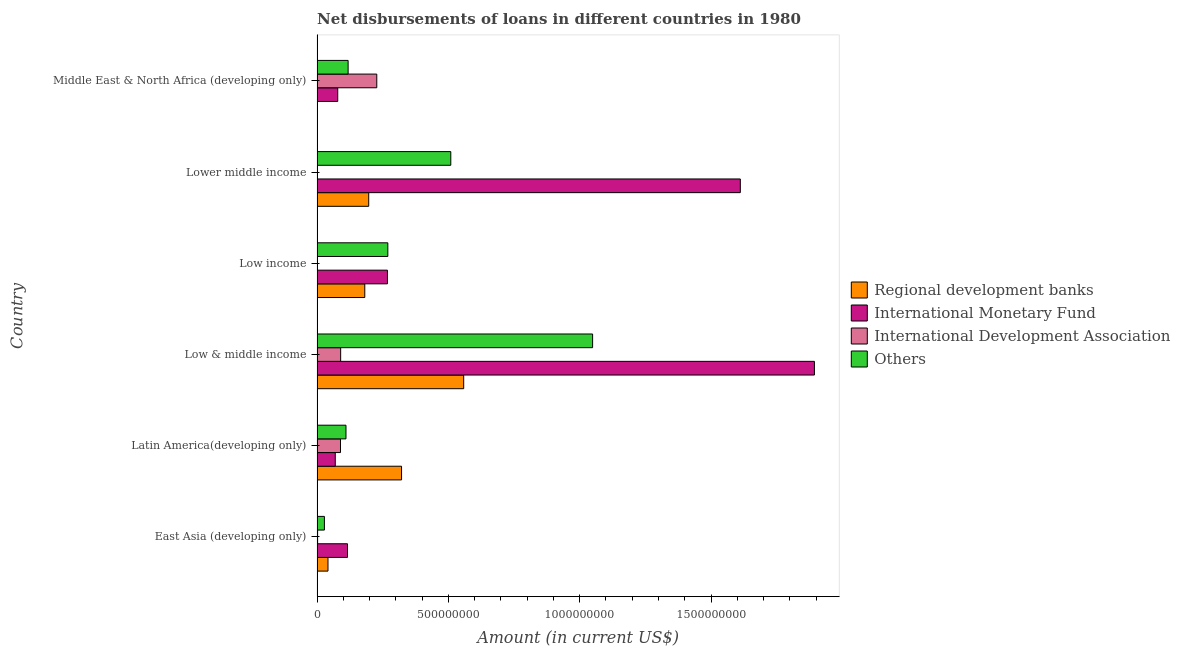How many different coloured bars are there?
Your answer should be compact. 4. How many groups of bars are there?
Offer a terse response. 6. Are the number of bars per tick equal to the number of legend labels?
Your answer should be compact. No. Are the number of bars on each tick of the Y-axis equal?
Ensure brevity in your answer.  No. How many bars are there on the 1st tick from the top?
Ensure brevity in your answer.  4. How many bars are there on the 4th tick from the bottom?
Your answer should be very brief. 3. In how many cases, is the number of bars for a given country not equal to the number of legend labels?
Your response must be concise. 2. What is the amount of loan disimbursed by other organisations in Low & middle income?
Give a very brief answer. 1.05e+09. Across all countries, what is the maximum amount of loan disimbursed by international development association?
Offer a very short reply. 2.27e+08. Across all countries, what is the minimum amount of loan disimbursed by international monetary fund?
Your answer should be very brief. 6.94e+07. What is the total amount of loan disimbursed by international development association in the graph?
Your answer should be very brief. 4.09e+08. What is the difference between the amount of loan disimbursed by international development association in Low & middle income and that in Middle East & North Africa (developing only)?
Offer a terse response. -1.38e+08. What is the difference between the amount of loan disimbursed by international monetary fund in Middle East & North Africa (developing only) and the amount of loan disimbursed by regional development banks in East Asia (developing only)?
Keep it short and to the point. 3.71e+07. What is the average amount of loan disimbursed by regional development banks per country?
Provide a short and direct response. 2.17e+08. What is the difference between the amount of loan disimbursed by regional development banks and amount of loan disimbursed by other organisations in Lower middle income?
Your answer should be very brief. -3.13e+08. In how many countries, is the amount of loan disimbursed by regional development banks greater than 100000000 US$?
Make the answer very short. 4. What is the ratio of the amount of loan disimbursed by other organisations in Latin America(developing only) to that in Middle East & North Africa (developing only)?
Provide a succinct answer. 0.93. Is the amount of loan disimbursed by international development association in East Asia (developing only) less than that in Low & middle income?
Keep it short and to the point. Yes. What is the difference between the highest and the second highest amount of loan disimbursed by other organisations?
Provide a succinct answer. 5.40e+08. What is the difference between the highest and the lowest amount of loan disimbursed by international development association?
Offer a terse response. 2.27e+08. In how many countries, is the amount of loan disimbursed by regional development banks greater than the average amount of loan disimbursed by regional development banks taken over all countries?
Your response must be concise. 2. Is the sum of the amount of loan disimbursed by international monetary fund in East Asia (developing only) and Middle East & North Africa (developing only) greater than the maximum amount of loan disimbursed by regional development banks across all countries?
Provide a succinct answer. No. Are all the bars in the graph horizontal?
Provide a short and direct response. Yes. What is the difference between two consecutive major ticks on the X-axis?
Provide a succinct answer. 5.00e+08. Does the graph contain any zero values?
Your answer should be very brief. Yes. Where does the legend appear in the graph?
Give a very brief answer. Center right. How many legend labels are there?
Give a very brief answer. 4. What is the title of the graph?
Give a very brief answer. Net disbursements of loans in different countries in 1980. What is the label or title of the Y-axis?
Provide a succinct answer. Country. What is the Amount (in current US$) of Regional development banks in East Asia (developing only)?
Your answer should be compact. 4.16e+07. What is the Amount (in current US$) in International Monetary Fund in East Asia (developing only)?
Provide a succinct answer. 1.16e+08. What is the Amount (in current US$) in International Development Association in East Asia (developing only)?
Ensure brevity in your answer.  2.14e+06. What is the Amount (in current US$) in Others in East Asia (developing only)?
Offer a very short reply. 2.80e+07. What is the Amount (in current US$) in Regional development banks in Latin America(developing only)?
Make the answer very short. 3.22e+08. What is the Amount (in current US$) of International Monetary Fund in Latin America(developing only)?
Ensure brevity in your answer.  6.94e+07. What is the Amount (in current US$) in International Development Association in Latin America(developing only)?
Provide a succinct answer. 8.93e+07. What is the Amount (in current US$) in Others in Latin America(developing only)?
Offer a very short reply. 1.10e+08. What is the Amount (in current US$) of Regional development banks in Low & middle income?
Your answer should be compact. 5.58e+08. What is the Amount (in current US$) of International Monetary Fund in Low & middle income?
Keep it short and to the point. 1.89e+09. What is the Amount (in current US$) of International Development Association in Low & middle income?
Your answer should be compact. 8.99e+07. What is the Amount (in current US$) in Others in Low & middle income?
Your response must be concise. 1.05e+09. What is the Amount (in current US$) of Regional development banks in Low income?
Provide a succinct answer. 1.82e+08. What is the Amount (in current US$) of International Monetary Fund in Low income?
Ensure brevity in your answer.  2.68e+08. What is the Amount (in current US$) of International Development Association in Low income?
Give a very brief answer. 0. What is the Amount (in current US$) of Others in Low income?
Ensure brevity in your answer.  2.69e+08. What is the Amount (in current US$) in Regional development banks in Lower middle income?
Keep it short and to the point. 1.97e+08. What is the Amount (in current US$) in International Monetary Fund in Lower middle income?
Offer a terse response. 1.61e+09. What is the Amount (in current US$) of Others in Lower middle income?
Your answer should be compact. 5.09e+08. What is the Amount (in current US$) of Regional development banks in Middle East & North Africa (developing only)?
Your answer should be very brief. 3.45e+05. What is the Amount (in current US$) of International Monetary Fund in Middle East & North Africa (developing only)?
Offer a terse response. 7.88e+07. What is the Amount (in current US$) in International Development Association in Middle East & North Africa (developing only)?
Your answer should be very brief. 2.27e+08. What is the Amount (in current US$) of Others in Middle East & North Africa (developing only)?
Keep it short and to the point. 1.18e+08. Across all countries, what is the maximum Amount (in current US$) in Regional development banks?
Ensure brevity in your answer.  5.58e+08. Across all countries, what is the maximum Amount (in current US$) in International Monetary Fund?
Offer a terse response. 1.89e+09. Across all countries, what is the maximum Amount (in current US$) in International Development Association?
Keep it short and to the point. 2.27e+08. Across all countries, what is the maximum Amount (in current US$) of Others?
Your answer should be compact. 1.05e+09. Across all countries, what is the minimum Amount (in current US$) in Regional development banks?
Your response must be concise. 3.45e+05. Across all countries, what is the minimum Amount (in current US$) of International Monetary Fund?
Offer a very short reply. 6.94e+07. Across all countries, what is the minimum Amount (in current US$) in Others?
Provide a short and direct response. 2.80e+07. What is the total Amount (in current US$) in Regional development banks in the graph?
Provide a succinct answer. 1.30e+09. What is the total Amount (in current US$) in International Monetary Fund in the graph?
Give a very brief answer. 4.04e+09. What is the total Amount (in current US$) in International Development Association in the graph?
Your answer should be very brief. 4.09e+08. What is the total Amount (in current US$) of Others in the graph?
Ensure brevity in your answer.  2.08e+09. What is the difference between the Amount (in current US$) in Regional development banks in East Asia (developing only) and that in Latin America(developing only)?
Provide a short and direct response. -2.80e+08. What is the difference between the Amount (in current US$) of International Monetary Fund in East Asia (developing only) and that in Latin America(developing only)?
Keep it short and to the point. 4.65e+07. What is the difference between the Amount (in current US$) of International Development Association in East Asia (developing only) and that in Latin America(developing only)?
Offer a very short reply. -8.71e+07. What is the difference between the Amount (in current US$) in Others in East Asia (developing only) and that in Latin America(developing only)?
Keep it short and to the point. -8.22e+07. What is the difference between the Amount (in current US$) of Regional development banks in East Asia (developing only) and that in Low & middle income?
Ensure brevity in your answer.  -5.17e+08. What is the difference between the Amount (in current US$) of International Monetary Fund in East Asia (developing only) and that in Low & middle income?
Keep it short and to the point. -1.78e+09. What is the difference between the Amount (in current US$) of International Development Association in East Asia (developing only) and that in Low & middle income?
Offer a terse response. -8.77e+07. What is the difference between the Amount (in current US$) of Others in East Asia (developing only) and that in Low & middle income?
Your response must be concise. -1.02e+09. What is the difference between the Amount (in current US$) in Regional development banks in East Asia (developing only) and that in Low income?
Your response must be concise. -1.40e+08. What is the difference between the Amount (in current US$) of International Monetary Fund in East Asia (developing only) and that in Low income?
Ensure brevity in your answer.  -1.52e+08. What is the difference between the Amount (in current US$) of Others in East Asia (developing only) and that in Low income?
Make the answer very short. -2.41e+08. What is the difference between the Amount (in current US$) of Regional development banks in East Asia (developing only) and that in Lower middle income?
Make the answer very short. -1.55e+08. What is the difference between the Amount (in current US$) in International Monetary Fund in East Asia (developing only) and that in Lower middle income?
Your answer should be very brief. -1.50e+09. What is the difference between the Amount (in current US$) of Others in East Asia (developing only) and that in Lower middle income?
Make the answer very short. -4.81e+08. What is the difference between the Amount (in current US$) in Regional development banks in East Asia (developing only) and that in Middle East & North Africa (developing only)?
Keep it short and to the point. 4.13e+07. What is the difference between the Amount (in current US$) in International Monetary Fund in East Asia (developing only) and that in Middle East & North Africa (developing only)?
Your response must be concise. 3.71e+07. What is the difference between the Amount (in current US$) of International Development Association in East Asia (developing only) and that in Middle East & North Africa (developing only)?
Your answer should be compact. -2.25e+08. What is the difference between the Amount (in current US$) in Others in East Asia (developing only) and that in Middle East & North Africa (developing only)?
Make the answer very short. -9.03e+07. What is the difference between the Amount (in current US$) in Regional development banks in Latin America(developing only) and that in Low & middle income?
Give a very brief answer. -2.37e+08. What is the difference between the Amount (in current US$) of International Monetary Fund in Latin America(developing only) and that in Low & middle income?
Give a very brief answer. -1.82e+09. What is the difference between the Amount (in current US$) of International Development Association in Latin America(developing only) and that in Low & middle income?
Provide a short and direct response. -6.00e+05. What is the difference between the Amount (in current US$) of Others in Latin America(developing only) and that in Low & middle income?
Ensure brevity in your answer.  -9.39e+08. What is the difference between the Amount (in current US$) of Regional development banks in Latin America(developing only) and that in Low income?
Your answer should be compact. 1.40e+08. What is the difference between the Amount (in current US$) of International Monetary Fund in Latin America(developing only) and that in Low income?
Ensure brevity in your answer.  -1.99e+08. What is the difference between the Amount (in current US$) in Others in Latin America(developing only) and that in Low income?
Give a very brief answer. -1.59e+08. What is the difference between the Amount (in current US$) of Regional development banks in Latin America(developing only) and that in Lower middle income?
Your response must be concise. 1.25e+08. What is the difference between the Amount (in current US$) in International Monetary Fund in Latin America(developing only) and that in Lower middle income?
Make the answer very short. -1.54e+09. What is the difference between the Amount (in current US$) of Others in Latin America(developing only) and that in Lower middle income?
Offer a terse response. -3.99e+08. What is the difference between the Amount (in current US$) of Regional development banks in Latin America(developing only) and that in Middle East & North Africa (developing only)?
Keep it short and to the point. 3.21e+08. What is the difference between the Amount (in current US$) of International Monetary Fund in Latin America(developing only) and that in Middle East & North Africa (developing only)?
Ensure brevity in your answer.  -9.39e+06. What is the difference between the Amount (in current US$) of International Development Association in Latin America(developing only) and that in Middle East & North Africa (developing only)?
Give a very brief answer. -1.38e+08. What is the difference between the Amount (in current US$) in Others in Latin America(developing only) and that in Middle East & North Africa (developing only)?
Your answer should be very brief. -8.12e+06. What is the difference between the Amount (in current US$) of Regional development banks in Low & middle income and that in Low income?
Provide a short and direct response. 3.77e+08. What is the difference between the Amount (in current US$) in International Monetary Fund in Low & middle income and that in Low income?
Your answer should be compact. 1.63e+09. What is the difference between the Amount (in current US$) in Others in Low & middle income and that in Low income?
Provide a short and direct response. 7.80e+08. What is the difference between the Amount (in current US$) in Regional development banks in Low & middle income and that in Lower middle income?
Your answer should be very brief. 3.62e+08. What is the difference between the Amount (in current US$) of International Monetary Fund in Low & middle income and that in Lower middle income?
Give a very brief answer. 2.82e+08. What is the difference between the Amount (in current US$) of Others in Low & middle income and that in Lower middle income?
Provide a short and direct response. 5.40e+08. What is the difference between the Amount (in current US$) in Regional development banks in Low & middle income and that in Middle East & North Africa (developing only)?
Ensure brevity in your answer.  5.58e+08. What is the difference between the Amount (in current US$) in International Monetary Fund in Low & middle income and that in Middle East & North Africa (developing only)?
Make the answer very short. 1.81e+09. What is the difference between the Amount (in current US$) in International Development Association in Low & middle income and that in Middle East & North Africa (developing only)?
Offer a terse response. -1.38e+08. What is the difference between the Amount (in current US$) in Others in Low & middle income and that in Middle East & North Africa (developing only)?
Keep it short and to the point. 9.31e+08. What is the difference between the Amount (in current US$) in Regional development banks in Low income and that in Lower middle income?
Offer a very short reply. -1.50e+07. What is the difference between the Amount (in current US$) of International Monetary Fund in Low income and that in Lower middle income?
Your answer should be compact. -1.34e+09. What is the difference between the Amount (in current US$) of Others in Low income and that in Lower middle income?
Keep it short and to the point. -2.40e+08. What is the difference between the Amount (in current US$) of Regional development banks in Low income and that in Middle East & North Africa (developing only)?
Provide a succinct answer. 1.81e+08. What is the difference between the Amount (in current US$) in International Monetary Fund in Low income and that in Middle East & North Africa (developing only)?
Keep it short and to the point. 1.89e+08. What is the difference between the Amount (in current US$) in Others in Low income and that in Middle East & North Africa (developing only)?
Make the answer very short. 1.51e+08. What is the difference between the Amount (in current US$) in Regional development banks in Lower middle income and that in Middle East & North Africa (developing only)?
Keep it short and to the point. 1.96e+08. What is the difference between the Amount (in current US$) in International Monetary Fund in Lower middle income and that in Middle East & North Africa (developing only)?
Your answer should be very brief. 1.53e+09. What is the difference between the Amount (in current US$) in Others in Lower middle income and that in Middle East & North Africa (developing only)?
Offer a very short reply. 3.91e+08. What is the difference between the Amount (in current US$) of Regional development banks in East Asia (developing only) and the Amount (in current US$) of International Monetary Fund in Latin America(developing only)?
Your response must be concise. -2.78e+07. What is the difference between the Amount (in current US$) of Regional development banks in East Asia (developing only) and the Amount (in current US$) of International Development Association in Latin America(developing only)?
Ensure brevity in your answer.  -4.76e+07. What is the difference between the Amount (in current US$) of Regional development banks in East Asia (developing only) and the Amount (in current US$) of Others in Latin America(developing only)?
Your answer should be very brief. -6.86e+07. What is the difference between the Amount (in current US$) in International Monetary Fund in East Asia (developing only) and the Amount (in current US$) in International Development Association in Latin America(developing only)?
Your answer should be compact. 2.66e+07. What is the difference between the Amount (in current US$) in International Monetary Fund in East Asia (developing only) and the Amount (in current US$) in Others in Latin America(developing only)?
Keep it short and to the point. 5.67e+06. What is the difference between the Amount (in current US$) in International Development Association in East Asia (developing only) and the Amount (in current US$) in Others in Latin America(developing only)?
Your response must be concise. -1.08e+08. What is the difference between the Amount (in current US$) in Regional development banks in East Asia (developing only) and the Amount (in current US$) in International Monetary Fund in Low & middle income?
Offer a very short reply. -1.85e+09. What is the difference between the Amount (in current US$) of Regional development banks in East Asia (developing only) and the Amount (in current US$) of International Development Association in Low & middle income?
Your answer should be compact. -4.82e+07. What is the difference between the Amount (in current US$) of Regional development banks in East Asia (developing only) and the Amount (in current US$) of Others in Low & middle income?
Offer a very short reply. -1.01e+09. What is the difference between the Amount (in current US$) of International Monetary Fund in East Asia (developing only) and the Amount (in current US$) of International Development Association in Low & middle income?
Give a very brief answer. 2.60e+07. What is the difference between the Amount (in current US$) of International Monetary Fund in East Asia (developing only) and the Amount (in current US$) of Others in Low & middle income?
Make the answer very short. -9.33e+08. What is the difference between the Amount (in current US$) in International Development Association in East Asia (developing only) and the Amount (in current US$) in Others in Low & middle income?
Give a very brief answer. -1.05e+09. What is the difference between the Amount (in current US$) in Regional development banks in East Asia (developing only) and the Amount (in current US$) in International Monetary Fund in Low income?
Provide a short and direct response. -2.26e+08. What is the difference between the Amount (in current US$) in Regional development banks in East Asia (developing only) and the Amount (in current US$) in Others in Low income?
Provide a succinct answer. -2.28e+08. What is the difference between the Amount (in current US$) of International Monetary Fund in East Asia (developing only) and the Amount (in current US$) of Others in Low income?
Make the answer very short. -1.54e+08. What is the difference between the Amount (in current US$) in International Development Association in East Asia (developing only) and the Amount (in current US$) in Others in Low income?
Give a very brief answer. -2.67e+08. What is the difference between the Amount (in current US$) in Regional development banks in East Asia (developing only) and the Amount (in current US$) in International Monetary Fund in Lower middle income?
Make the answer very short. -1.57e+09. What is the difference between the Amount (in current US$) in Regional development banks in East Asia (developing only) and the Amount (in current US$) in Others in Lower middle income?
Provide a succinct answer. -4.68e+08. What is the difference between the Amount (in current US$) of International Monetary Fund in East Asia (developing only) and the Amount (in current US$) of Others in Lower middle income?
Your response must be concise. -3.93e+08. What is the difference between the Amount (in current US$) of International Development Association in East Asia (developing only) and the Amount (in current US$) of Others in Lower middle income?
Offer a very short reply. -5.07e+08. What is the difference between the Amount (in current US$) in Regional development banks in East Asia (developing only) and the Amount (in current US$) in International Monetary Fund in Middle East & North Africa (developing only)?
Ensure brevity in your answer.  -3.71e+07. What is the difference between the Amount (in current US$) in Regional development banks in East Asia (developing only) and the Amount (in current US$) in International Development Association in Middle East & North Africa (developing only)?
Keep it short and to the point. -1.86e+08. What is the difference between the Amount (in current US$) in Regional development banks in East Asia (developing only) and the Amount (in current US$) in Others in Middle East & North Africa (developing only)?
Provide a succinct answer. -7.67e+07. What is the difference between the Amount (in current US$) of International Monetary Fund in East Asia (developing only) and the Amount (in current US$) of International Development Association in Middle East & North Africa (developing only)?
Provide a short and direct response. -1.12e+08. What is the difference between the Amount (in current US$) in International Monetary Fund in East Asia (developing only) and the Amount (in current US$) in Others in Middle East & North Africa (developing only)?
Your answer should be compact. -2.45e+06. What is the difference between the Amount (in current US$) of International Development Association in East Asia (developing only) and the Amount (in current US$) of Others in Middle East & North Africa (developing only)?
Provide a short and direct response. -1.16e+08. What is the difference between the Amount (in current US$) of Regional development banks in Latin America(developing only) and the Amount (in current US$) of International Monetary Fund in Low & middle income?
Offer a very short reply. -1.57e+09. What is the difference between the Amount (in current US$) of Regional development banks in Latin America(developing only) and the Amount (in current US$) of International Development Association in Low & middle income?
Ensure brevity in your answer.  2.32e+08. What is the difference between the Amount (in current US$) in Regional development banks in Latin America(developing only) and the Amount (in current US$) in Others in Low & middle income?
Ensure brevity in your answer.  -7.27e+08. What is the difference between the Amount (in current US$) in International Monetary Fund in Latin America(developing only) and the Amount (in current US$) in International Development Association in Low & middle income?
Make the answer very short. -2.05e+07. What is the difference between the Amount (in current US$) in International Monetary Fund in Latin America(developing only) and the Amount (in current US$) in Others in Low & middle income?
Make the answer very short. -9.80e+08. What is the difference between the Amount (in current US$) in International Development Association in Latin America(developing only) and the Amount (in current US$) in Others in Low & middle income?
Ensure brevity in your answer.  -9.60e+08. What is the difference between the Amount (in current US$) of Regional development banks in Latin America(developing only) and the Amount (in current US$) of International Monetary Fund in Low income?
Ensure brevity in your answer.  5.37e+07. What is the difference between the Amount (in current US$) of Regional development banks in Latin America(developing only) and the Amount (in current US$) of Others in Low income?
Keep it short and to the point. 5.22e+07. What is the difference between the Amount (in current US$) in International Monetary Fund in Latin America(developing only) and the Amount (in current US$) in Others in Low income?
Offer a terse response. -2.00e+08. What is the difference between the Amount (in current US$) in International Development Association in Latin America(developing only) and the Amount (in current US$) in Others in Low income?
Make the answer very short. -1.80e+08. What is the difference between the Amount (in current US$) in Regional development banks in Latin America(developing only) and the Amount (in current US$) in International Monetary Fund in Lower middle income?
Give a very brief answer. -1.29e+09. What is the difference between the Amount (in current US$) of Regional development banks in Latin America(developing only) and the Amount (in current US$) of Others in Lower middle income?
Provide a short and direct response. -1.88e+08. What is the difference between the Amount (in current US$) of International Monetary Fund in Latin America(developing only) and the Amount (in current US$) of Others in Lower middle income?
Make the answer very short. -4.40e+08. What is the difference between the Amount (in current US$) of International Development Association in Latin America(developing only) and the Amount (in current US$) of Others in Lower middle income?
Your answer should be very brief. -4.20e+08. What is the difference between the Amount (in current US$) in Regional development banks in Latin America(developing only) and the Amount (in current US$) in International Monetary Fund in Middle East & North Africa (developing only)?
Offer a very short reply. 2.43e+08. What is the difference between the Amount (in current US$) in Regional development banks in Latin America(developing only) and the Amount (in current US$) in International Development Association in Middle East & North Africa (developing only)?
Offer a very short reply. 9.43e+07. What is the difference between the Amount (in current US$) of Regional development banks in Latin America(developing only) and the Amount (in current US$) of Others in Middle East & North Africa (developing only)?
Your response must be concise. 2.03e+08. What is the difference between the Amount (in current US$) of International Monetary Fund in Latin America(developing only) and the Amount (in current US$) of International Development Association in Middle East & North Africa (developing only)?
Provide a succinct answer. -1.58e+08. What is the difference between the Amount (in current US$) in International Monetary Fund in Latin America(developing only) and the Amount (in current US$) in Others in Middle East & North Africa (developing only)?
Give a very brief answer. -4.89e+07. What is the difference between the Amount (in current US$) of International Development Association in Latin America(developing only) and the Amount (in current US$) of Others in Middle East & North Africa (developing only)?
Your answer should be very brief. -2.90e+07. What is the difference between the Amount (in current US$) of Regional development banks in Low & middle income and the Amount (in current US$) of International Monetary Fund in Low income?
Your answer should be very brief. 2.90e+08. What is the difference between the Amount (in current US$) in Regional development banks in Low & middle income and the Amount (in current US$) in Others in Low income?
Your answer should be very brief. 2.89e+08. What is the difference between the Amount (in current US$) of International Monetary Fund in Low & middle income and the Amount (in current US$) of Others in Low income?
Provide a succinct answer. 1.62e+09. What is the difference between the Amount (in current US$) of International Development Association in Low & middle income and the Amount (in current US$) of Others in Low income?
Your response must be concise. -1.80e+08. What is the difference between the Amount (in current US$) of Regional development banks in Low & middle income and the Amount (in current US$) of International Monetary Fund in Lower middle income?
Provide a succinct answer. -1.05e+09. What is the difference between the Amount (in current US$) in Regional development banks in Low & middle income and the Amount (in current US$) in Others in Lower middle income?
Give a very brief answer. 4.91e+07. What is the difference between the Amount (in current US$) of International Monetary Fund in Low & middle income and the Amount (in current US$) of Others in Lower middle income?
Your response must be concise. 1.38e+09. What is the difference between the Amount (in current US$) in International Development Association in Low & middle income and the Amount (in current US$) in Others in Lower middle income?
Keep it short and to the point. -4.19e+08. What is the difference between the Amount (in current US$) of Regional development banks in Low & middle income and the Amount (in current US$) of International Monetary Fund in Middle East & North Africa (developing only)?
Offer a very short reply. 4.80e+08. What is the difference between the Amount (in current US$) in Regional development banks in Low & middle income and the Amount (in current US$) in International Development Association in Middle East & North Africa (developing only)?
Provide a short and direct response. 3.31e+08. What is the difference between the Amount (in current US$) of Regional development banks in Low & middle income and the Amount (in current US$) of Others in Middle East & North Africa (developing only)?
Offer a very short reply. 4.40e+08. What is the difference between the Amount (in current US$) of International Monetary Fund in Low & middle income and the Amount (in current US$) of International Development Association in Middle East & North Africa (developing only)?
Make the answer very short. 1.67e+09. What is the difference between the Amount (in current US$) in International Monetary Fund in Low & middle income and the Amount (in current US$) in Others in Middle East & North Africa (developing only)?
Give a very brief answer. 1.78e+09. What is the difference between the Amount (in current US$) of International Development Association in Low & middle income and the Amount (in current US$) of Others in Middle East & North Africa (developing only)?
Your response must be concise. -2.84e+07. What is the difference between the Amount (in current US$) of Regional development banks in Low income and the Amount (in current US$) of International Monetary Fund in Lower middle income?
Offer a very short reply. -1.43e+09. What is the difference between the Amount (in current US$) of Regional development banks in Low income and the Amount (in current US$) of Others in Lower middle income?
Offer a terse response. -3.27e+08. What is the difference between the Amount (in current US$) in International Monetary Fund in Low income and the Amount (in current US$) in Others in Lower middle income?
Ensure brevity in your answer.  -2.41e+08. What is the difference between the Amount (in current US$) in Regional development banks in Low income and the Amount (in current US$) in International Monetary Fund in Middle East & North Africa (developing only)?
Keep it short and to the point. 1.03e+08. What is the difference between the Amount (in current US$) of Regional development banks in Low income and the Amount (in current US$) of International Development Association in Middle East & North Africa (developing only)?
Offer a terse response. -4.56e+07. What is the difference between the Amount (in current US$) in Regional development banks in Low income and the Amount (in current US$) in Others in Middle East & North Africa (developing only)?
Give a very brief answer. 6.34e+07. What is the difference between the Amount (in current US$) of International Monetary Fund in Low income and the Amount (in current US$) of International Development Association in Middle East & North Africa (developing only)?
Make the answer very short. 4.06e+07. What is the difference between the Amount (in current US$) of International Monetary Fund in Low income and the Amount (in current US$) of Others in Middle East & North Africa (developing only)?
Keep it short and to the point. 1.50e+08. What is the difference between the Amount (in current US$) in Regional development banks in Lower middle income and the Amount (in current US$) in International Monetary Fund in Middle East & North Africa (developing only)?
Offer a very short reply. 1.18e+08. What is the difference between the Amount (in current US$) of Regional development banks in Lower middle income and the Amount (in current US$) of International Development Association in Middle East & North Africa (developing only)?
Make the answer very short. -3.07e+07. What is the difference between the Amount (in current US$) in Regional development banks in Lower middle income and the Amount (in current US$) in Others in Middle East & North Africa (developing only)?
Ensure brevity in your answer.  7.84e+07. What is the difference between the Amount (in current US$) of International Monetary Fund in Lower middle income and the Amount (in current US$) of International Development Association in Middle East & North Africa (developing only)?
Give a very brief answer. 1.38e+09. What is the difference between the Amount (in current US$) of International Monetary Fund in Lower middle income and the Amount (in current US$) of Others in Middle East & North Africa (developing only)?
Provide a short and direct response. 1.49e+09. What is the average Amount (in current US$) in Regional development banks per country?
Offer a terse response. 2.17e+08. What is the average Amount (in current US$) in International Monetary Fund per country?
Your answer should be compact. 6.73e+08. What is the average Amount (in current US$) of International Development Association per country?
Give a very brief answer. 6.81e+07. What is the average Amount (in current US$) in Others per country?
Provide a short and direct response. 3.47e+08. What is the difference between the Amount (in current US$) of Regional development banks and Amount (in current US$) of International Monetary Fund in East Asia (developing only)?
Provide a succinct answer. -7.42e+07. What is the difference between the Amount (in current US$) of Regional development banks and Amount (in current US$) of International Development Association in East Asia (developing only)?
Provide a short and direct response. 3.95e+07. What is the difference between the Amount (in current US$) in Regional development banks and Amount (in current US$) in Others in East Asia (developing only)?
Ensure brevity in your answer.  1.36e+07. What is the difference between the Amount (in current US$) in International Monetary Fund and Amount (in current US$) in International Development Association in East Asia (developing only)?
Your response must be concise. 1.14e+08. What is the difference between the Amount (in current US$) of International Monetary Fund and Amount (in current US$) of Others in East Asia (developing only)?
Provide a short and direct response. 8.78e+07. What is the difference between the Amount (in current US$) in International Development Association and Amount (in current US$) in Others in East Asia (developing only)?
Your answer should be very brief. -2.59e+07. What is the difference between the Amount (in current US$) in Regional development banks and Amount (in current US$) in International Monetary Fund in Latin America(developing only)?
Provide a short and direct response. 2.52e+08. What is the difference between the Amount (in current US$) in Regional development banks and Amount (in current US$) in International Development Association in Latin America(developing only)?
Make the answer very short. 2.32e+08. What is the difference between the Amount (in current US$) in Regional development banks and Amount (in current US$) in Others in Latin America(developing only)?
Offer a very short reply. 2.12e+08. What is the difference between the Amount (in current US$) in International Monetary Fund and Amount (in current US$) in International Development Association in Latin America(developing only)?
Offer a very short reply. -1.99e+07. What is the difference between the Amount (in current US$) of International Monetary Fund and Amount (in current US$) of Others in Latin America(developing only)?
Provide a short and direct response. -4.08e+07. What is the difference between the Amount (in current US$) of International Development Association and Amount (in current US$) of Others in Latin America(developing only)?
Give a very brief answer. -2.09e+07. What is the difference between the Amount (in current US$) of Regional development banks and Amount (in current US$) of International Monetary Fund in Low & middle income?
Ensure brevity in your answer.  -1.34e+09. What is the difference between the Amount (in current US$) in Regional development banks and Amount (in current US$) in International Development Association in Low & middle income?
Give a very brief answer. 4.68e+08. What is the difference between the Amount (in current US$) in Regional development banks and Amount (in current US$) in Others in Low & middle income?
Keep it short and to the point. -4.91e+08. What is the difference between the Amount (in current US$) of International Monetary Fund and Amount (in current US$) of International Development Association in Low & middle income?
Your response must be concise. 1.80e+09. What is the difference between the Amount (in current US$) in International Monetary Fund and Amount (in current US$) in Others in Low & middle income?
Give a very brief answer. 8.45e+08. What is the difference between the Amount (in current US$) of International Development Association and Amount (in current US$) of Others in Low & middle income?
Give a very brief answer. -9.59e+08. What is the difference between the Amount (in current US$) in Regional development banks and Amount (in current US$) in International Monetary Fund in Low income?
Keep it short and to the point. -8.63e+07. What is the difference between the Amount (in current US$) of Regional development banks and Amount (in current US$) of Others in Low income?
Your response must be concise. -8.78e+07. What is the difference between the Amount (in current US$) of International Monetary Fund and Amount (in current US$) of Others in Low income?
Provide a succinct answer. -1.49e+06. What is the difference between the Amount (in current US$) of Regional development banks and Amount (in current US$) of International Monetary Fund in Lower middle income?
Your answer should be compact. -1.41e+09. What is the difference between the Amount (in current US$) in Regional development banks and Amount (in current US$) in Others in Lower middle income?
Ensure brevity in your answer.  -3.13e+08. What is the difference between the Amount (in current US$) of International Monetary Fund and Amount (in current US$) of Others in Lower middle income?
Provide a succinct answer. 1.10e+09. What is the difference between the Amount (in current US$) of Regional development banks and Amount (in current US$) of International Monetary Fund in Middle East & North Africa (developing only)?
Make the answer very short. -7.84e+07. What is the difference between the Amount (in current US$) of Regional development banks and Amount (in current US$) of International Development Association in Middle East & North Africa (developing only)?
Provide a short and direct response. -2.27e+08. What is the difference between the Amount (in current US$) in Regional development banks and Amount (in current US$) in Others in Middle East & North Africa (developing only)?
Your answer should be very brief. -1.18e+08. What is the difference between the Amount (in current US$) in International Monetary Fund and Amount (in current US$) in International Development Association in Middle East & North Africa (developing only)?
Your answer should be very brief. -1.49e+08. What is the difference between the Amount (in current US$) of International Monetary Fund and Amount (in current US$) of Others in Middle East & North Africa (developing only)?
Your answer should be compact. -3.95e+07. What is the difference between the Amount (in current US$) of International Development Association and Amount (in current US$) of Others in Middle East & North Africa (developing only)?
Ensure brevity in your answer.  1.09e+08. What is the ratio of the Amount (in current US$) of Regional development banks in East Asia (developing only) to that in Latin America(developing only)?
Provide a succinct answer. 0.13. What is the ratio of the Amount (in current US$) of International Monetary Fund in East Asia (developing only) to that in Latin America(developing only)?
Ensure brevity in your answer.  1.67. What is the ratio of the Amount (in current US$) of International Development Association in East Asia (developing only) to that in Latin America(developing only)?
Offer a very short reply. 0.02. What is the ratio of the Amount (in current US$) of Others in East Asia (developing only) to that in Latin America(developing only)?
Keep it short and to the point. 0.25. What is the ratio of the Amount (in current US$) of Regional development banks in East Asia (developing only) to that in Low & middle income?
Provide a succinct answer. 0.07. What is the ratio of the Amount (in current US$) in International Monetary Fund in East Asia (developing only) to that in Low & middle income?
Your answer should be compact. 0.06. What is the ratio of the Amount (in current US$) in International Development Association in East Asia (developing only) to that in Low & middle income?
Keep it short and to the point. 0.02. What is the ratio of the Amount (in current US$) of Others in East Asia (developing only) to that in Low & middle income?
Offer a very short reply. 0.03. What is the ratio of the Amount (in current US$) of Regional development banks in East Asia (developing only) to that in Low income?
Ensure brevity in your answer.  0.23. What is the ratio of the Amount (in current US$) in International Monetary Fund in East Asia (developing only) to that in Low income?
Your answer should be compact. 0.43. What is the ratio of the Amount (in current US$) in Others in East Asia (developing only) to that in Low income?
Make the answer very short. 0.1. What is the ratio of the Amount (in current US$) in Regional development banks in East Asia (developing only) to that in Lower middle income?
Your answer should be very brief. 0.21. What is the ratio of the Amount (in current US$) in International Monetary Fund in East Asia (developing only) to that in Lower middle income?
Provide a succinct answer. 0.07. What is the ratio of the Amount (in current US$) in Others in East Asia (developing only) to that in Lower middle income?
Ensure brevity in your answer.  0.06. What is the ratio of the Amount (in current US$) in Regional development banks in East Asia (developing only) to that in Middle East & North Africa (developing only)?
Your answer should be very brief. 120.63. What is the ratio of the Amount (in current US$) of International Monetary Fund in East Asia (developing only) to that in Middle East & North Africa (developing only)?
Your response must be concise. 1.47. What is the ratio of the Amount (in current US$) in International Development Association in East Asia (developing only) to that in Middle East & North Africa (developing only)?
Your answer should be compact. 0.01. What is the ratio of the Amount (in current US$) in Others in East Asia (developing only) to that in Middle East & North Africa (developing only)?
Provide a short and direct response. 0.24. What is the ratio of the Amount (in current US$) in Regional development banks in Latin America(developing only) to that in Low & middle income?
Offer a terse response. 0.58. What is the ratio of the Amount (in current US$) in International Monetary Fund in Latin America(developing only) to that in Low & middle income?
Offer a terse response. 0.04. What is the ratio of the Amount (in current US$) of Others in Latin America(developing only) to that in Low & middle income?
Make the answer very short. 0.1. What is the ratio of the Amount (in current US$) of Regional development banks in Latin America(developing only) to that in Low income?
Your answer should be compact. 1.77. What is the ratio of the Amount (in current US$) of International Monetary Fund in Latin America(developing only) to that in Low income?
Offer a terse response. 0.26. What is the ratio of the Amount (in current US$) in Others in Latin America(developing only) to that in Low income?
Your answer should be very brief. 0.41. What is the ratio of the Amount (in current US$) in Regional development banks in Latin America(developing only) to that in Lower middle income?
Provide a succinct answer. 1.64. What is the ratio of the Amount (in current US$) of International Monetary Fund in Latin America(developing only) to that in Lower middle income?
Provide a succinct answer. 0.04. What is the ratio of the Amount (in current US$) in Others in Latin America(developing only) to that in Lower middle income?
Provide a succinct answer. 0.22. What is the ratio of the Amount (in current US$) in Regional development banks in Latin America(developing only) to that in Middle East & North Africa (developing only)?
Your answer should be compact. 932.46. What is the ratio of the Amount (in current US$) of International Monetary Fund in Latin America(developing only) to that in Middle East & North Africa (developing only)?
Your answer should be very brief. 0.88. What is the ratio of the Amount (in current US$) in International Development Association in Latin America(developing only) to that in Middle East & North Africa (developing only)?
Your response must be concise. 0.39. What is the ratio of the Amount (in current US$) of Others in Latin America(developing only) to that in Middle East & North Africa (developing only)?
Offer a terse response. 0.93. What is the ratio of the Amount (in current US$) of Regional development banks in Low & middle income to that in Low income?
Offer a very short reply. 3.07. What is the ratio of the Amount (in current US$) of International Monetary Fund in Low & middle income to that in Low income?
Make the answer very short. 7.07. What is the ratio of the Amount (in current US$) in Others in Low & middle income to that in Low income?
Make the answer very short. 3.89. What is the ratio of the Amount (in current US$) of Regional development banks in Low & middle income to that in Lower middle income?
Your response must be concise. 2.84. What is the ratio of the Amount (in current US$) in International Monetary Fund in Low & middle income to that in Lower middle income?
Provide a short and direct response. 1.18. What is the ratio of the Amount (in current US$) of Others in Low & middle income to that in Lower middle income?
Your answer should be very brief. 2.06. What is the ratio of the Amount (in current US$) of Regional development banks in Low & middle income to that in Middle East & North Africa (developing only)?
Your answer should be compact. 1618.33. What is the ratio of the Amount (in current US$) of International Monetary Fund in Low & middle income to that in Middle East & North Africa (developing only)?
Provide a short and direct response. 24.04. What is the ratio of the Amount (in current US$) of International Development Association in Low & middle income to that in Middle East & North Africa (developing only)?
Your response must be concise. 0.4. What is the ratio of the Amount (in current US$) in Others in Low & middle income to that in Middle East & North Africa (developing only)?
Give a very brief answer. 8.87. What is the ratio of the Amount (in current US$) of Regional development banks in Low income to that in Lower middle income?
Give a very brief answer. 0.92. What is the ratio of the Amount (in current US$) of International Monetary Fund in Low income to that in Lower middle income?
Provide a succinct answer. 0.17. What is the ratio of the Amount (in current US$) in Others in Low income to that in Lower middle income?
Give a very brief answer. 0.53. What is the ratio of the Amount (in current US$) of Regional development banks in Low income to that in Middle East & North Africa (developing only)?
Ensure brevity in your answer.  526.79. What is the ratio of the Amount (in current US$) in International Monetary Fund in Low income to that in Middle East & North Africa (developing only)?
Your answer should be compact. 3.4. What is the ratio of the Amount (in current US$) in Others in Low income to that in Middle East & North Africa (developing only)?
Make the answer very short. 2.28. What is the ratio of the Amount (in current US$) in Regional development banks in Lower middle income to that in Middle East & North Africa (developing only)?
Your response must be concise. 570.15. What is the ratio of the Amount (in current US$) in International Monetary Fund in Lower middle income to that in Middle East & North Africa (developing only)?
Make the answer very short. 20.46. What is the ratio of the Amount (in current US$) in Others in Lower middle income to that in Middle East & North Africa (developing only)?
Give a very brief answer. 4.3. What is the difference between the highest and the second highest Amount (in current US$) of Regional development banks?
Ensure brevity in your answer.  2.37e+08. What is the difference between the highest and the second highest Amount (in current US$) in International Monetary Fund?
Give a very brief answer. 2.82e+08. What is the difference between the highest and the second highest Amount (in current US$) of International Development Association?
Offer a terse response. 1.38e+08. What is the difference between the highest and the second highest Amount (in current US$) of Others?
Your response must be concise. 5.40e+08. What is the difference between the highest and the lowest Amount (in current US$) of Regional development banks?
Provide a succinct answer. 5.58e+08. What is the difference between the highest and the lowest Amount (in current US$) in International Monetary Fund?
Your answer should be compact. 1.82e+09. What is the difference between the highest and the lowest Amount (in current US$) of International Development Association?
Offer a terse response. 2.27e+08. What is the difference between the highest and the lowest Amount (in current US$) of Others?
Provide a succinct answer. 1.02e+09. 